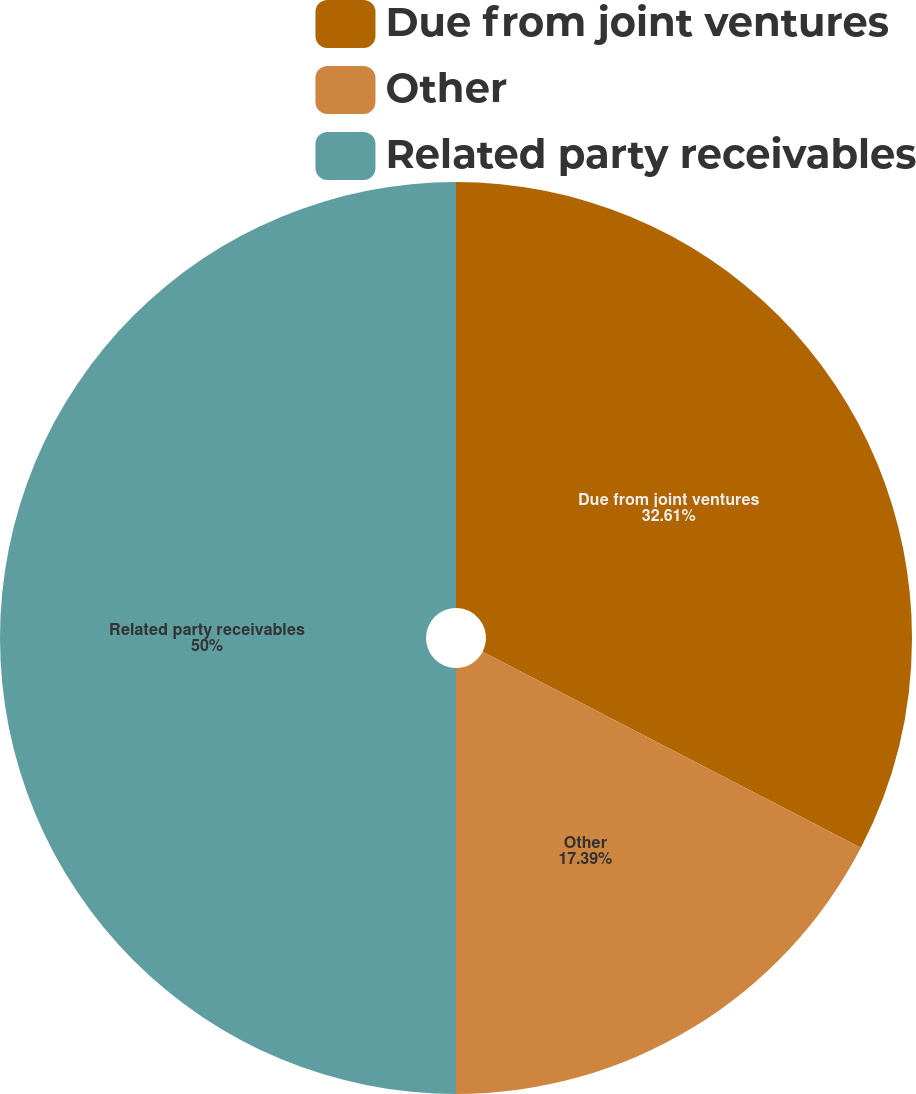<chart> <loc_0><loc_0><loc_500><loc_500><pie_chart><fcel>Due from joint ventures<fcel>Other<fcel>Related party receivables<nl><fcel>32.61%<fcel>17.39%<fcel>50.0%<nl></chart> 